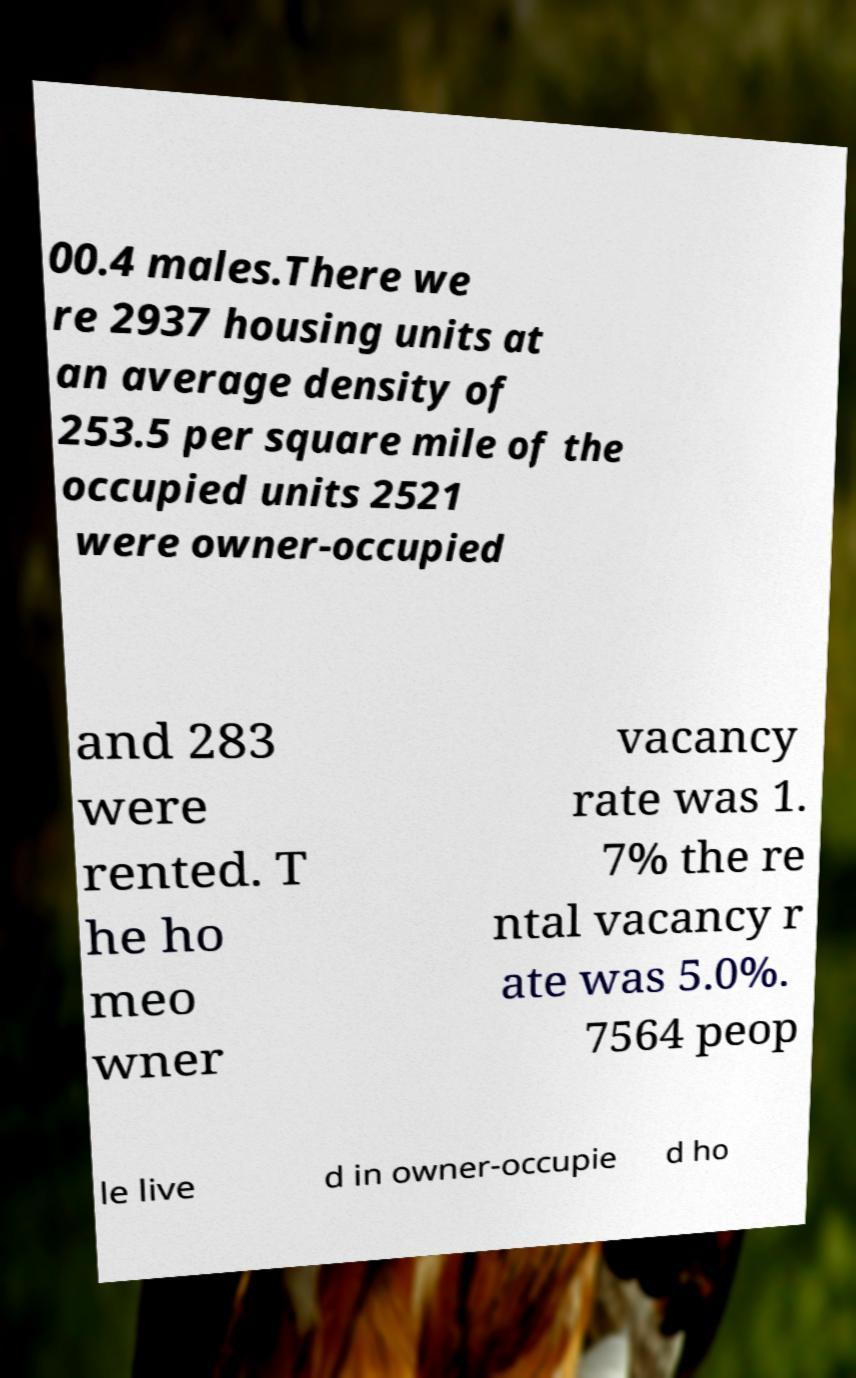Please identify and transcribe the text found in this image. 00.4 males.There we re 2937 housing units at an average density of 253.5 per square mile of the occupied units 2521 were owner-occupied and 283 were rented. T he ho meo wner vacancy rate was 1. 7% the re ntal vacancy r ate was 5.0%. 7564 peop le live d in owner-occupie d ho 